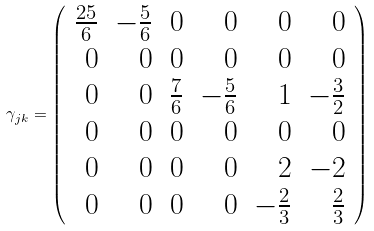Convert formula to latex. <formula><loc_0><loc_0><loc_500><loc_500>\gamma _ { j k } = \left ( \begin{array} { r r r r r r } \frac { 2 5 } { 6 } & - \frac { 5 } { 6 } & 0 & 0 & 0 & 0 \\ 0 & 0 & 0 & 0 & 0 & 0 \\ 0 & 0 & \frac { 7 } { 6 } & - \frac { 5 } { 6 } & 1 & - \frac { 3 } { 2 } \\ 0 & 0 & 0 & 0 & 0 & 0 \\ 0 & 0 & 0 & 0 & 2 & - 2 \\ 0 & 0 & 0 & 0 & - \frac { 2 } { 3 } & \frac { 2 } { 3 } \end{array} \right )</formula> 